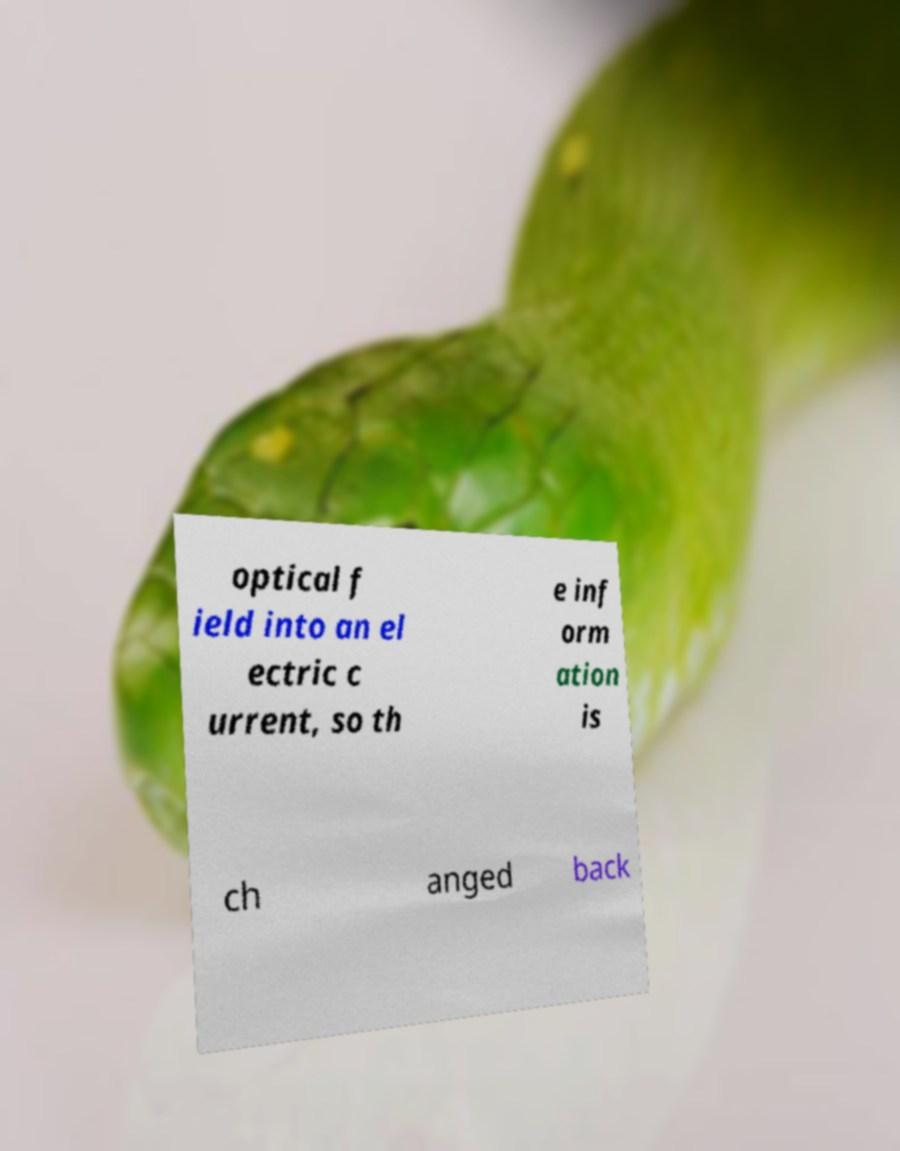What messages or text are displayed in this image? I need them in a readable, typed format. optical f ield into an el ectric c urrent, so th e inf orm ation is ch anged back 